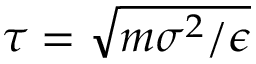<formula> <loc_0><loc_0><loc_500><loc_500>\tau = \sqrt { m \sigma ^ { 2 } / \epsilon }</formula> 